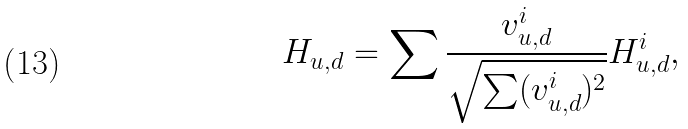<formula> <loc_0><loc_0><loc_500><loc_500>H _ { u , d } = \sum \frac { v ^ { i } _ { u , d } } { \sqrt { \sum ( v ^ { i } _ { u , d } ) ^ { 2 } } } H ^ { i } _ { u , d } ,</formula> 